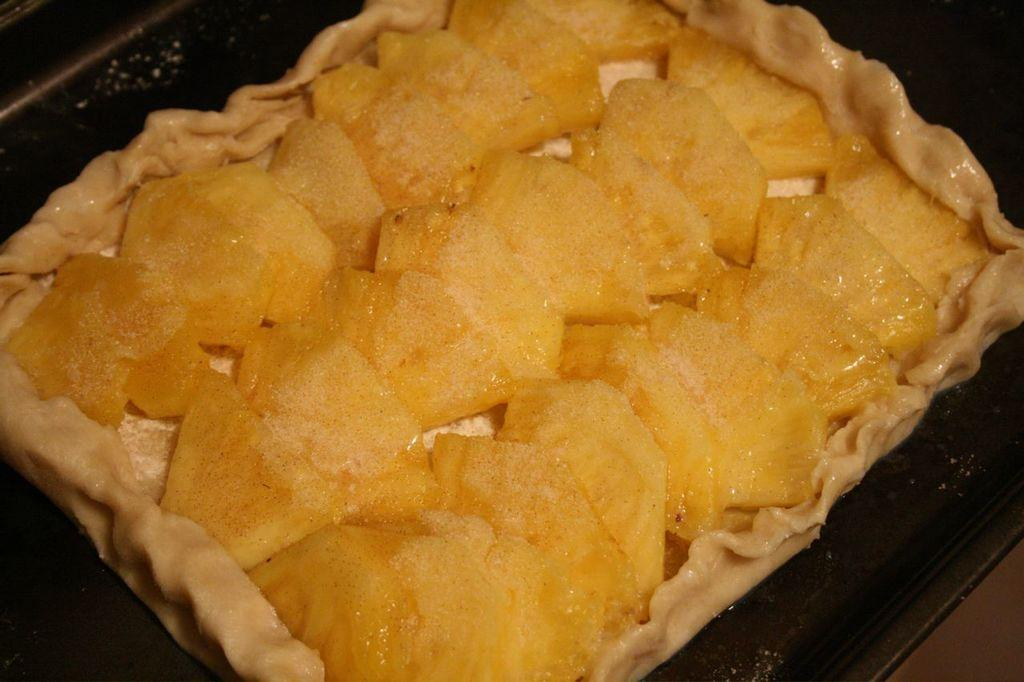What is on the plate in the image? There is food on a plate in the image. What type of tank can be seen in the image? There is no tank present in the image; it only features a plate of food. Is it raining in the image? The image does not provide any information about the weather, so it cannot be determined if it is raining. 